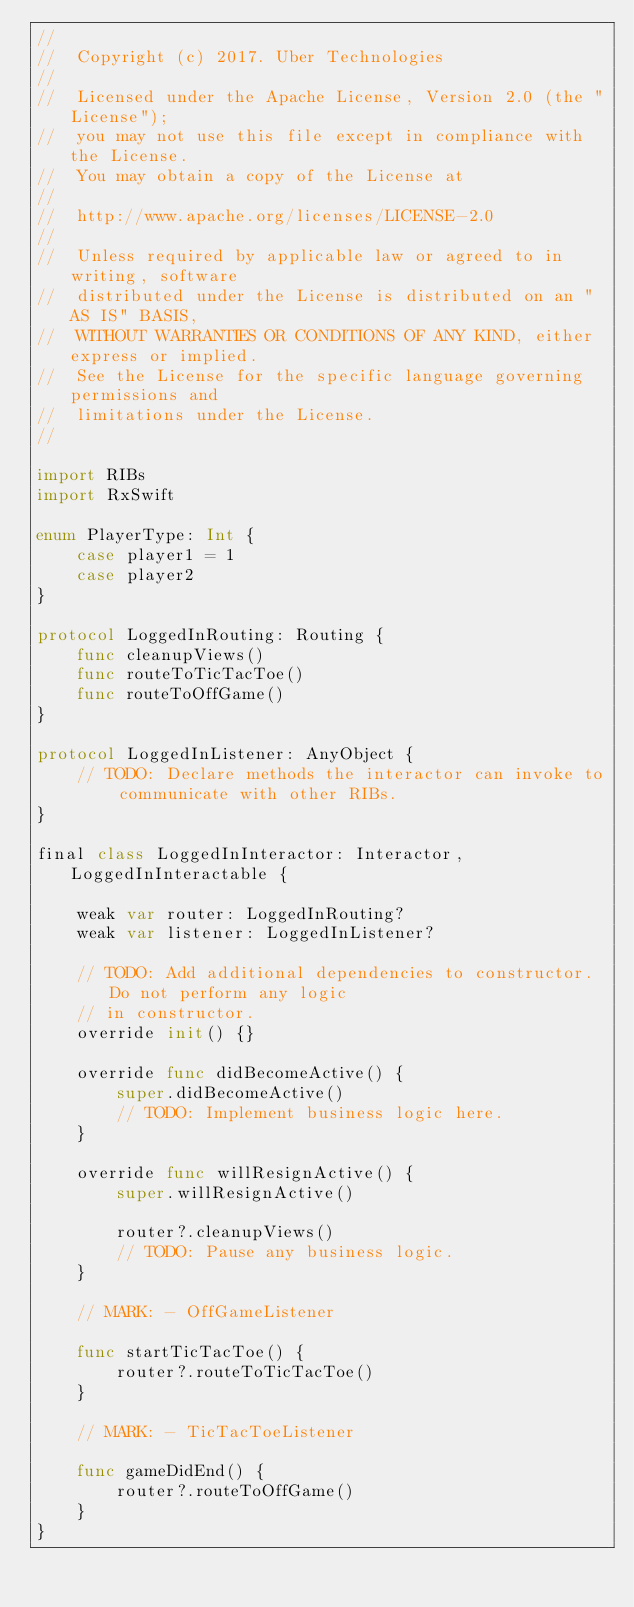Convert code to text. <code><loc_0><loc_0><loc_500><loc_500><_Swift_>//
//  Copyright (c) 2017. Uber Technologies
//
//  Licensed under the Apache License, Version 2.0 (the "License");
//  you may not use this file except in compliance with the License.
//  You may obtain a copy of the License at
//
//  http://www.apache.org/licenses/LICENSE-2.0
//
//  Unless required by applicable law or agreed to in writing, software
//  distributed under the License is distributed on an "AS IS" BASIS,
//  WITHOUT WARRANTIES OR CONDITIONS OF ANY KIND, either express or implied.
//  See the License for the specific language governing permissions and
//  limitations under the License.
//

import RIBs
import RxSwift

enum PlayerType: Int {
    case player1 = 1
    case player2
}

protocol LoggedInRouting: Routing {
    func cleanupViews()
    func routeToTicTacToe()
    func routeToOffGame()
}

protocol LoggedInListener: AnyObject {
    // TODO: Declare methods the interactor can invoke to communicate with other RIBs.
}

final class LoggedInInteractor: Interactor, LoggedInInteractable {

    weak var router: LoggedInRouting?
    weak var listener: LoggedInListener?

    // TODO: Add additional dependencies to constructor. Do not perform any logic
    // in constructor.
    override init() {}

    override func didBecomeActive() {
        super.didBecomeActive()
        // TODO: Implement business logic here.
    }

    override func willResignActive() {
        super.willResignActive()

        router?.cleanupViews()
        // TODO: Pause any business logic.
    }

    // MARK: - OffGameListener

    func startTicTacToe() {
        router?.routeToTicTacToe()
    }

    // MARK: - TicTacToeListener

    func gameDidEnd() {
        router?.routeToOffGame()
    }
}
</code> 